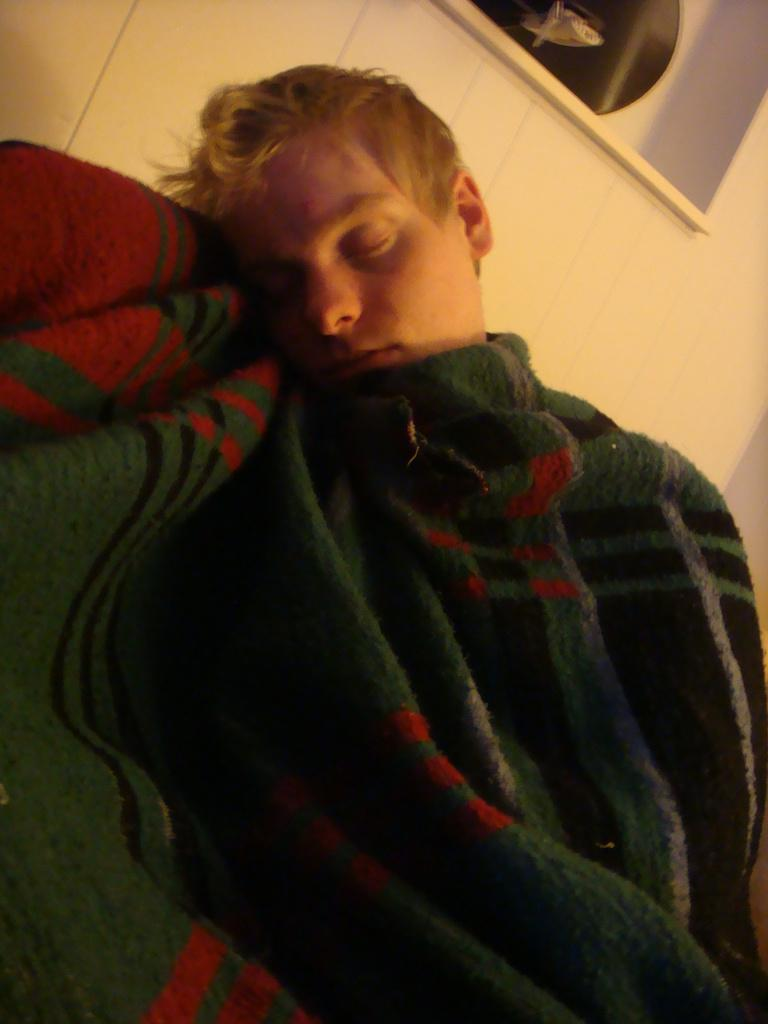What is the person in the image doing? The person is sleeping in the image. How is the person covered in the image? The person is covered by a blanket. What is visible behind the person in the image? There is a wall behind the person. What is on the wall in the image? There is a shelf on the wall. What can be seen on the shelf in the image? There are objects on the shelf. What type of flowers can be seen in the garden in the image? There is no garden present in the image; it features a person sleeping with a wall and a shelf in the background. 